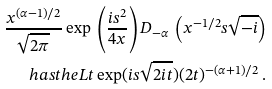<formula> <loc_0><loc_0><loc_500><loc_500>\frac { x ^ { ( \alpha - 1 ) / 2 } } { \sqrt { 2 \pi } } \exp \, \left ( \frac { i s ^ { 2 } } { 4 x } \right ) D _ { - \alpha } \, \left ( x ^ { - 1 / 2 } s \sqrt { - i } \right ) \\ h a s t h e L t \exp ( i s \sqrt { 2 i t } ) ( 2 t ) ^ { - ( \alpha + 1 ) / 2 } \, .</formula> 